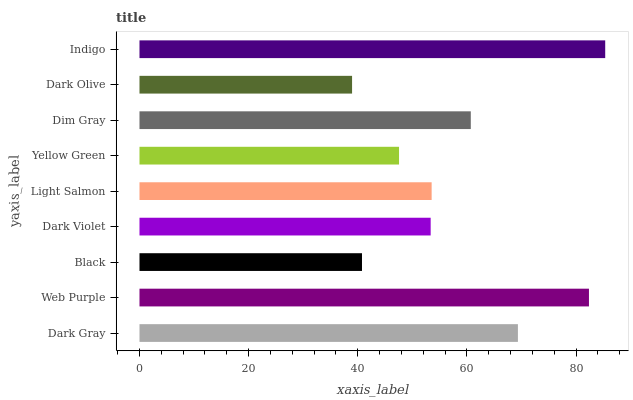Is Dark Olive the minimum?
Answer yes or no. Yes. Is Indigo the maximum?
Answer yes or no. Yes. Is Web Purple the minimum?
Answer yes or no. No. Is Web Purple the maximum?
Answer yes or no. No. Is Web Purple greater than Dark Gray?
Answer yes or no. Yes. Is Dark Gray less than Web Purple?
Answer yes or no. Yes. Is Dark Gray greater than Web Purple?
Answer yes or no. No. Is Web Purple less than Dark Gray?
Answer yes or no. No. Is Light Salmon the high median?
Answer yes or no. Yes. Is Light Salmon the low median?
Answer yes or no. Yes. Is Dark Gray the high median?
Answer yes or no. No. Is Dark Gray the low median?
Answer yes or no. No. 